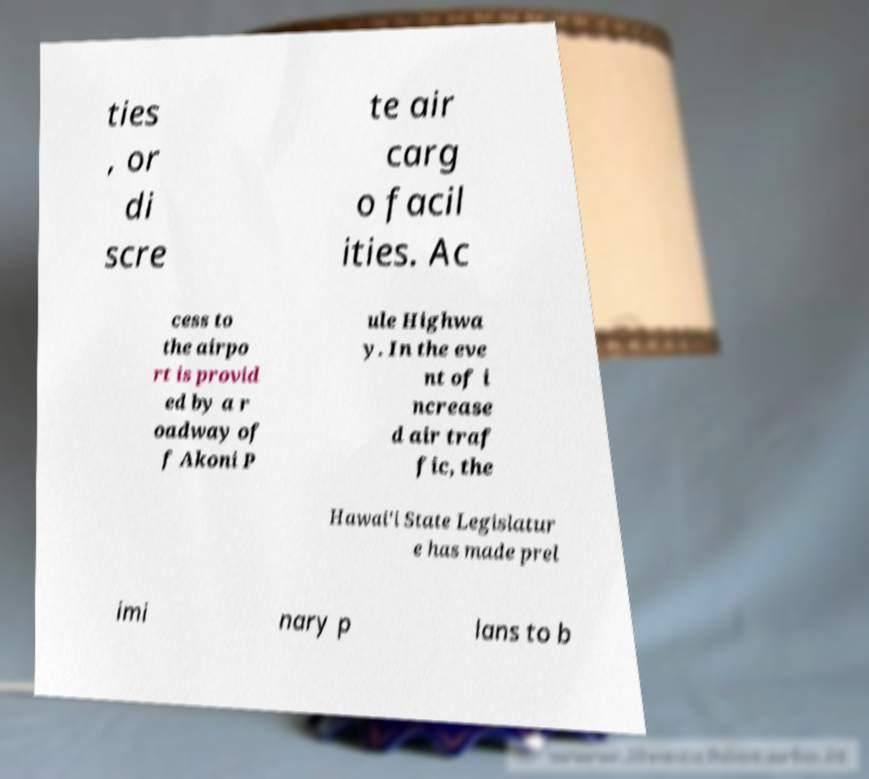Can you accurately transcribe the text from the provided image for me? ties , or di scre te air carg o facil ities. Ac cess to the airpo rt is provid ed by a r oadway of f Akoni P ule Highwa y. In the eve nt of i ncrease d air traf fic, the Hawai'i State Legislatur e has made prel imi nary p lans to b 